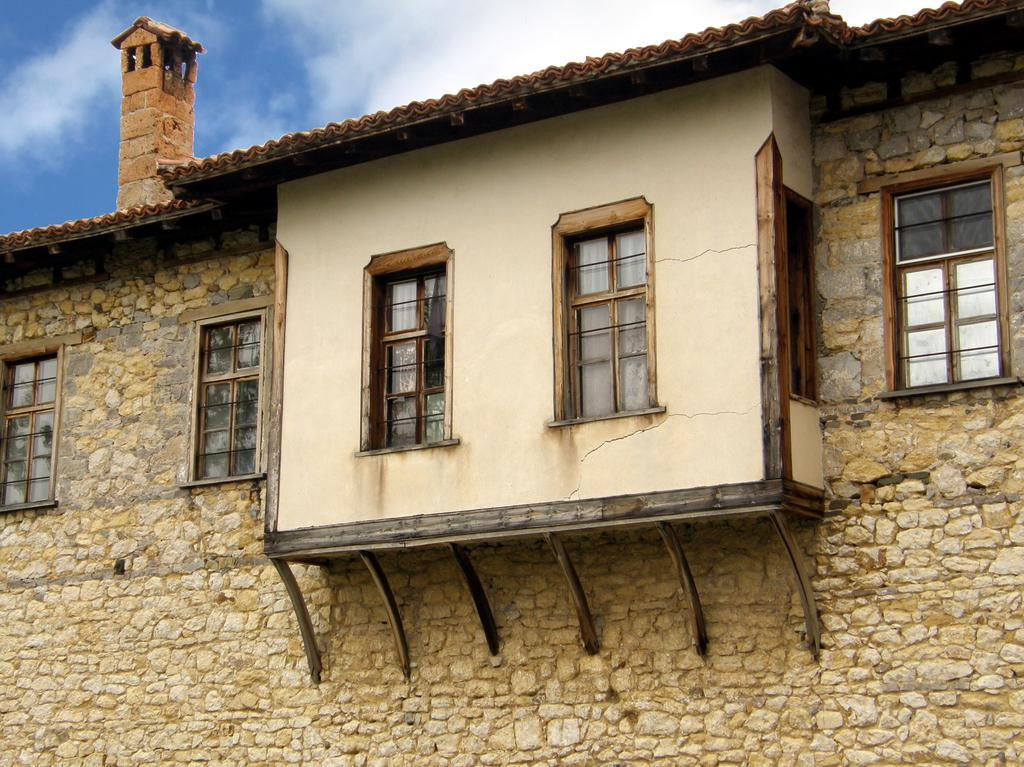What type of structure is visible in the image? There is a wall of a building in the image. What feature can be seen on the wall of the building? The wall has glass windows. What is visible at the top of the image? The sky is visible at the top of the image. What type of fruit is hanging from the windows in the image? There are no fruits hanging from the windows in the image; the windows are made of glass. How many hens can be seen on the wall of the building in the image? There are no hens present in the image; it only features a wall with glass windows and the sky visible at the top. 